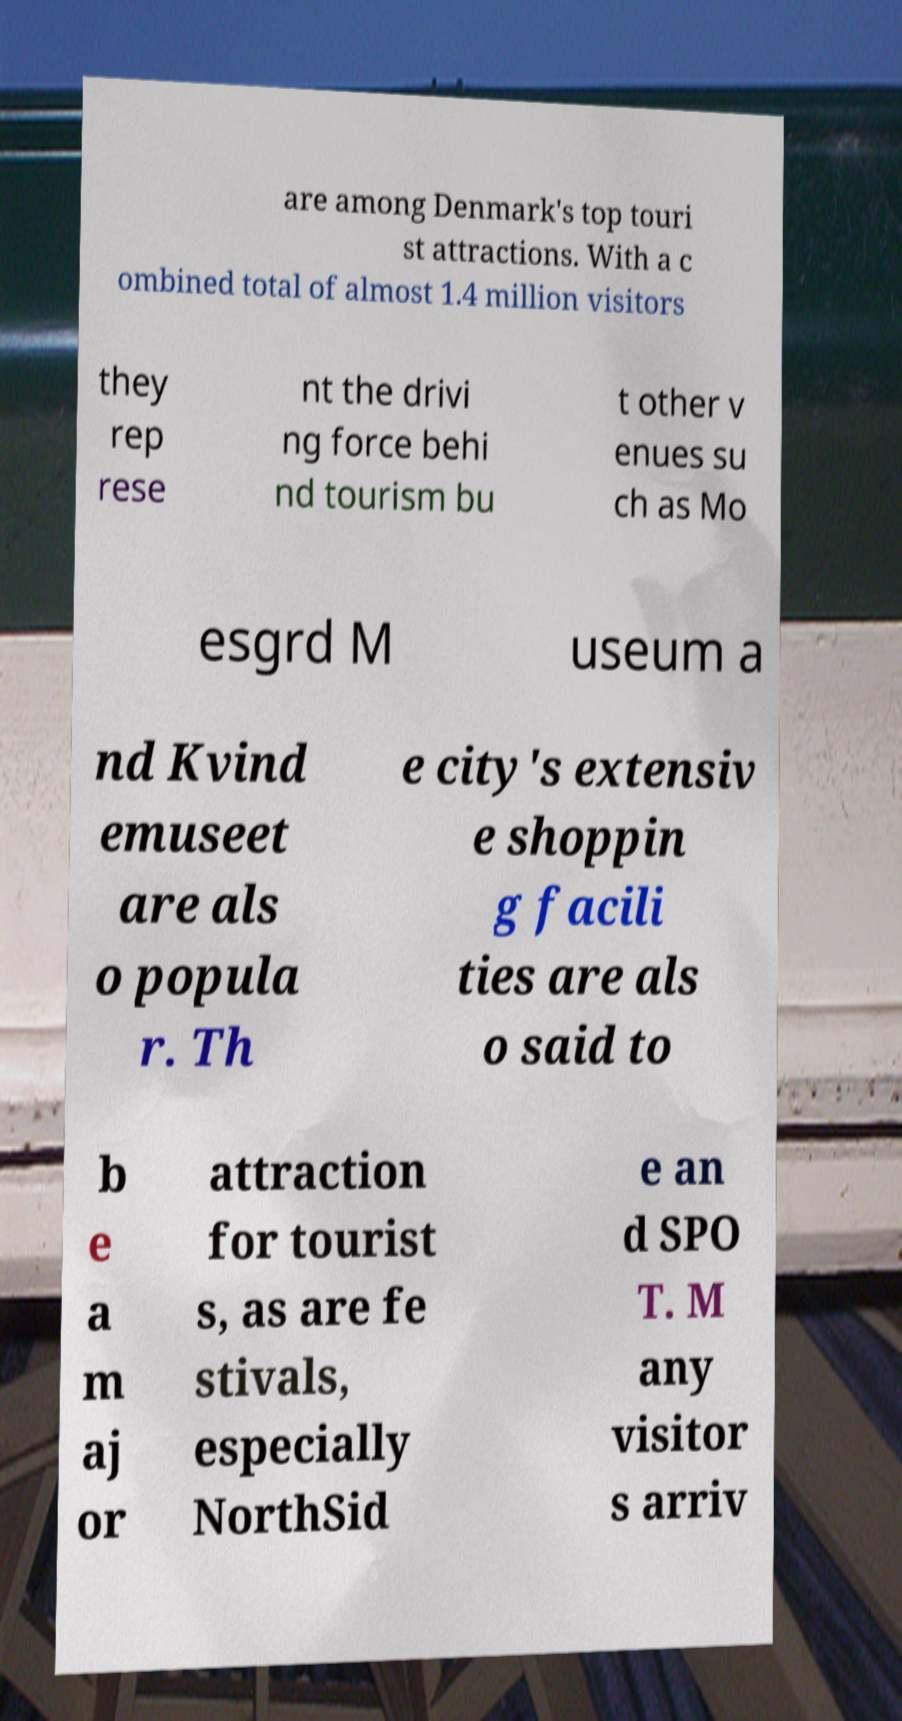For documentation purposes, I need the text within this image transcribed. Could you provide that? are among Denmark's top touri st attractions. With a c ombined total of almost 1.4 million visitors they rep rese nt the drivi ng force behi nd tourism bu t other v enues su ch as Mo esgrd M useum a nd Kvind emuseet are als o popula r. Th e city's extensiv e shoppin g facili ties are als o said to b e a m aj or attraction for tourist s, as are fe stivals, especially NorthSid e an d SPO T. M any visitor s arriv 